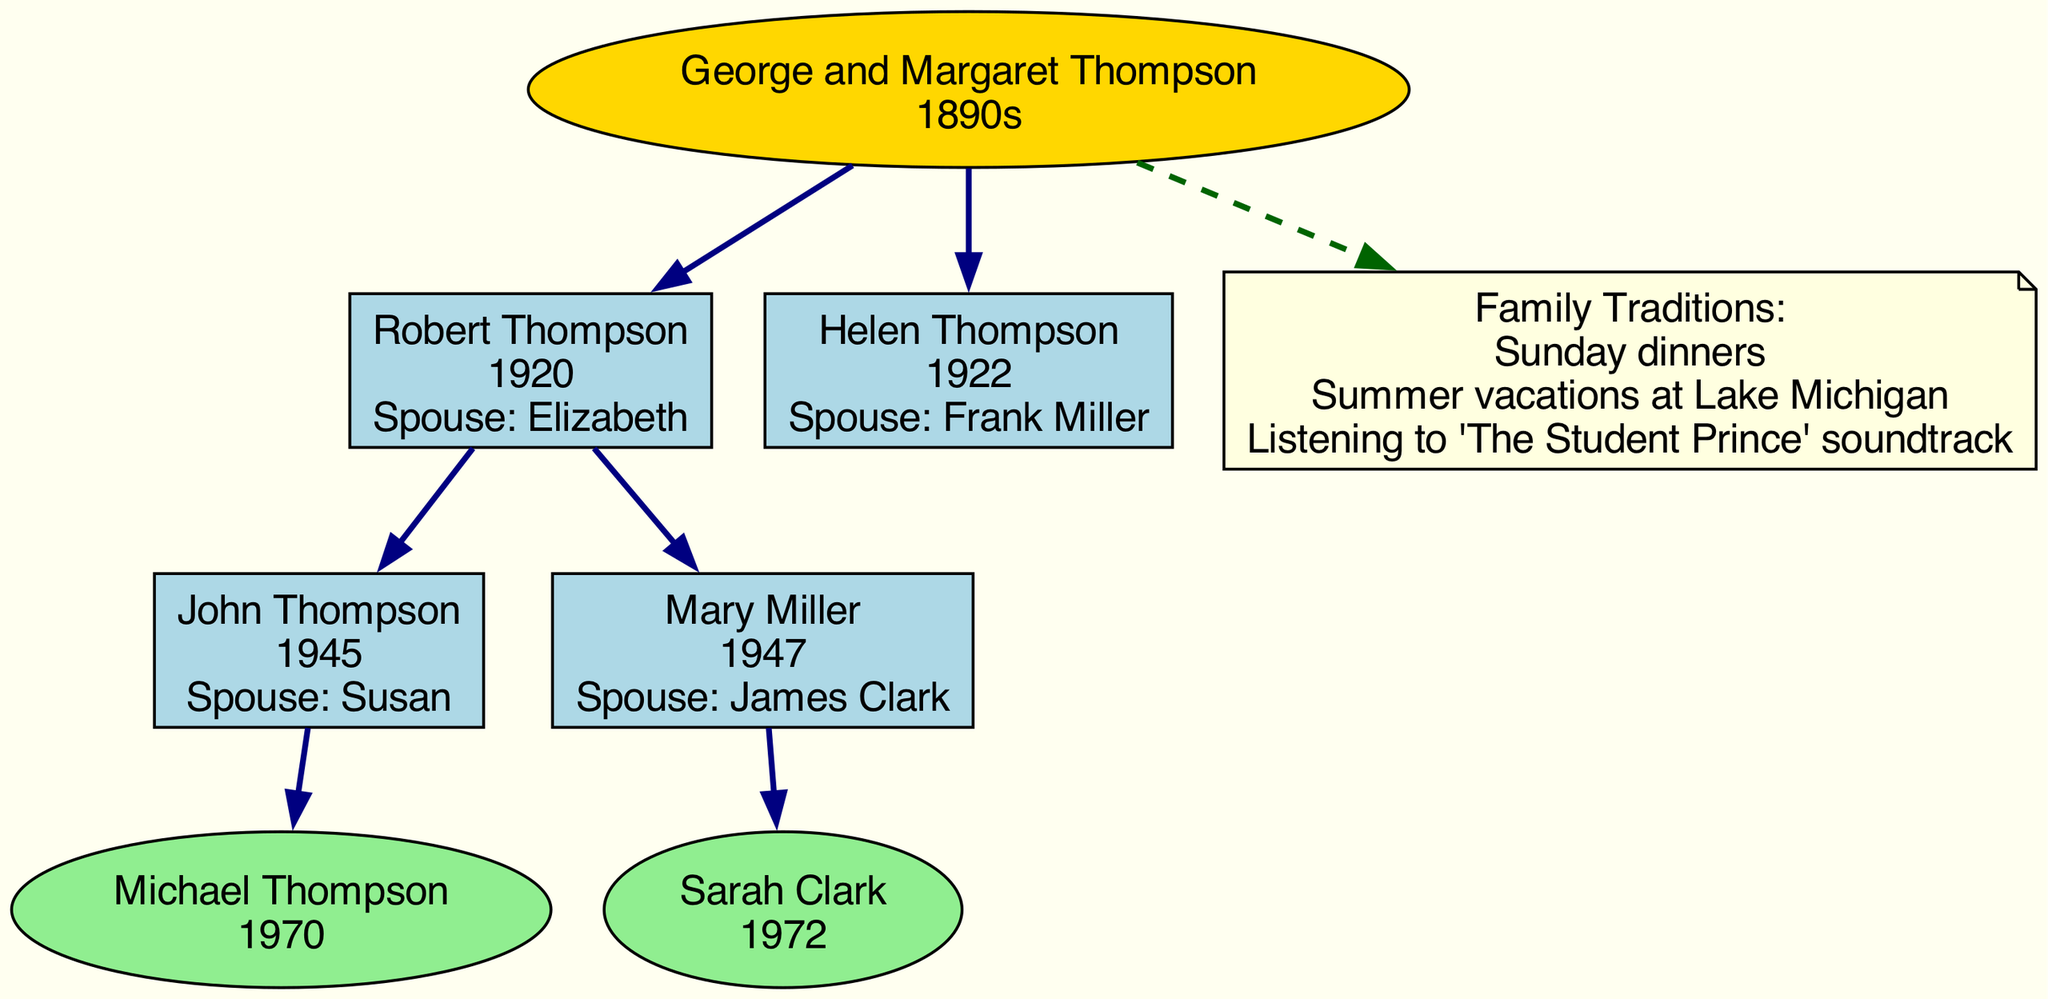What are the names of the individuals in the second generation? The second generation consists of Robert Thompson and Helen Thompson. These names can be found directly under the second generation section of the diagram, connected to the root generation, George and Margaret Thompson.
Answer: Robert Thompson, Helen Thompson How many members are in the fourth generation? There are two individuals in the fourth generation: Michael Thompson and Sarah Clark. The count can be determined by counting the nodes listed under the fourth generation in the diagram.
Answer: 2 Who is the spouse of John Thompson? John Thompson's spouse is Susan. This information is located adjacent to John Thompson in the third generation section of the diagram.
Answer: Susan Which family tradition involves a specific location? The family tradition that involves a specific location is "Summer vacations at Lake Michigan." This is specified in the family traditions section connected to the root generation and can be recognized by the mention of "Lake Michigan."
Answer: Summer vacations at Lake Michigan How is Mary Miller related to George and Margaret Thompson? Mary Miller is the granddaughter of George and Margaret Thompson. This relationship can be established by tracing the lineage from George and Margaret Thompson (the root generation) to their son Frank Miller (Helen's spouse), then to Mary Miller (their child).
Answer: Granddaughter What year was Robert Thompson born? Robert Thompson was born in 1920. This birth year is displayed directly next to his name in the second generation section of the diagram.
Answer: 1920 Who are the parents of Sarah Clark? The parents of Sarah Clark are Mary Miller and James Clark. This information is derived from the detailing of the third generation where Mary Miller is connected to Sarah Clark as her child.
Answer: Mary Miller, James Clark How many family traditions are listed in the diagram? There are three family traditions listed in the diagram: Sunday dinners, Summer vacations at Lake Michigan, and Listening to 'The Student Prince' soundtrack. This number is determined by counting the individual traditions presented in the family traditions section.
Answer: 3 